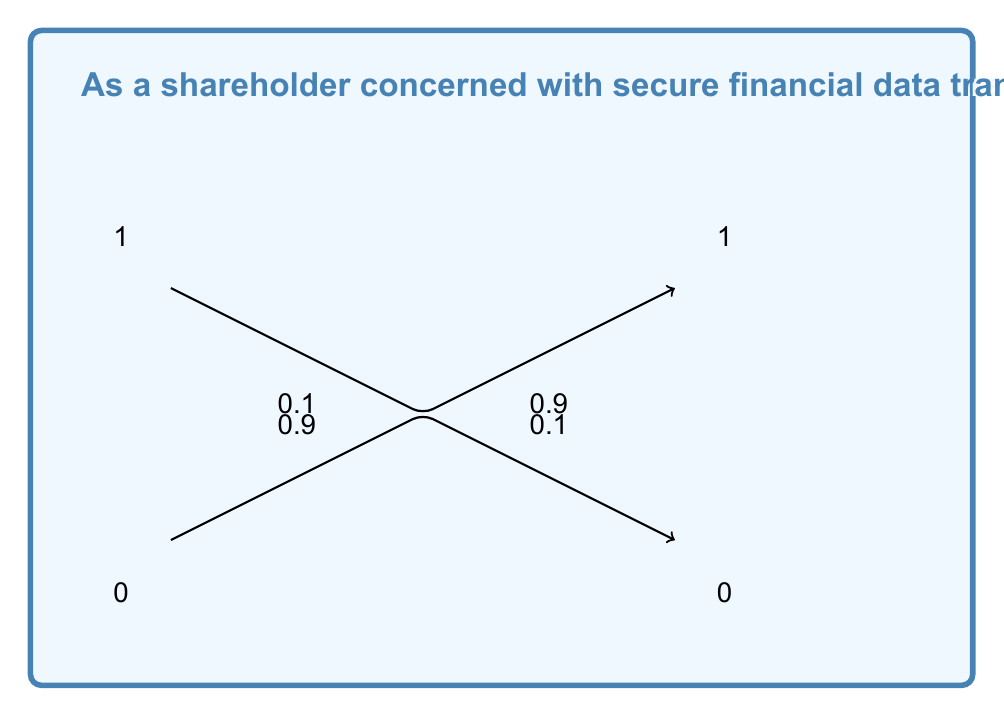Could you help me with this problem? To calculate the channel capacity, we'll use Shannon's theorem and follow these steps:

1) The channel capacity C is given by:
   $$C = B \log_2(1 + SNR)$$
   where B is the bandwidth and SNR is the signal-to-noise ratio.

2) For a binary symmetric channel, we can express the capacity in terms of the bit error rate p:
   $$C = 1 - H(p)$$
   where H(p) is the binary entropy function.

3) The binary entropy function is defined as:
   $$H(p) = -p \log_2(p) - (1-p) \log_2(1-p)$$

4) Given p = 0.1, let's calculate H(p):
   $$H(0.1) = -0.1 \log_2(0.1) - 0.9 \log_2(0.9)$$
   $$= 0.1 \cdot 3.32 + 0.9 \cdot 0.152$$
   $$= 0.332 + 0.137 = 0.469$$

5) Now we can calculate the capacity per bit:
   $$C = 1 - H(0.1) = 1 - 0.469 = 0.531$$

6) The system operates at 1 Mbps, so the total capacity in bits per second is:
   $$C_{total} = 1,000,000 \cdot 0.531 = 531,000 \text{ bps}$$

Therefore, the maximum theoretical channel capacity is 531,000 bits per second.
Answer: 531,000 bps 